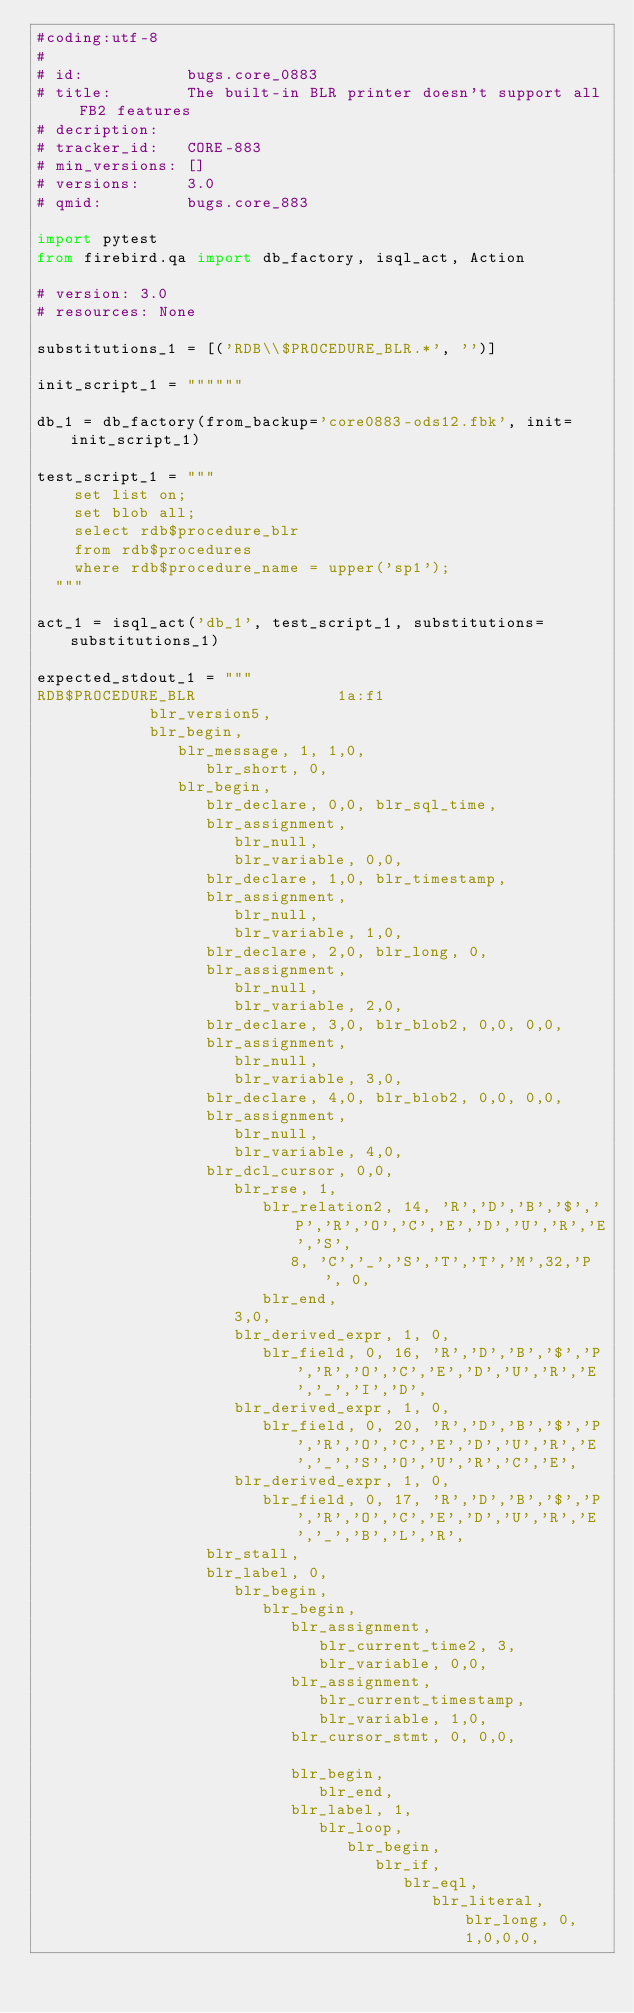<code> <loc_0><loc_0><loc_500><loc_500><_Python_>#coding:utf-8
#
# id:           bugs.core_0883
# title:        The built-in BLR printer doesn't support all FB2 features
# decription:   
# tracker_id:   CORE-883
# min_versions: []
# versions:     3.0
# qmid:         bugs.core_883

import pytest
from firebird.qa import db_factory, isql_act, Action

# version: 3.0
# resources: None

substitutions_1 = [('RDB\\$PROCEDURE_BLR.*', '')]

init_script_1 = """"""

db_1 = db_factory(from_backup='core0883-ods12.fbk', init=init_script_1)

test_script_1 = """
    set list on;
    set blob all;
    select rdb$procedure_blr
    from rdb$procedures
    where rdb$procedure_name = upper('sp1');
  """

act_1 = isql_act('db_1', test_script_1, substitutions=substitutions_1)

expected_stdout_1 = """
RDB$PROCEDURE_BLR               1a:f1
        	blr_version5,
        	blr_begin,
        	   blr_message, 1, 1,0,
        	      blr_short, 0,
        	   blr_begin,
        	      blr_declare, 0,0, blr_sql_time,
        	      blr_assignment,
        	         blr_null,
        	         blr_variable, 0,0,
        	      blr_declare, 1,0, blr_timestamp,
        	      blr_assignment,
        	         blr_null,
        	         blr_variable, 1,0,
        	      blr_declare, 2,0, blr_long, 0,
        	      blr_assignment,
        	         blr_null,
        	         blr_variable, 2,0,
        	      blr_declare, 3,0, blr_blob2, 0,0, 0,0,
        	      blr_assignment,
        	         blr_null,
        	         blr_variable, 3,0,
        	      blr_declare, 4,0, blr_blob2, 0,0, 0,0,
        	      blr_assignment,
        	         blr_null,
        	         blr_variable, 4,0,
        	      blr_dcl_cursor, 0,0,
        	         blr_rse, 1,
        	            blr_relation2, 14, 'R','D','B','$','P','R','O','C','E','D','U','R','E','S',
        	               8, 'C','_','S','T','T','M',32,'P', 0,
        	            blr_end,
        	         3,0,
        	         blr_derived_expr, 1, 0,
        	            blr_field, 0, 16, 'R','D','B','$','P','R','O','C','E','D','U','R','E','_','I','D',
        	         blr_derived_expr, 1, 0,
        	            blr_field, 0, 20, 'R','D','B','$','P','R','O','C','E','D','U','R','E','_','S','O','U','R','C','E',
        	         blr_derived_expr, 1, 0,
        	            blr_field, 0, 17, 'R','D','B','$','P','R','O','C','E','D','U','R','E','_','B','L','R',
        	      blr_stall,
        	      blr_label, 0,
        	         blr_begin,
        	            blr_begin,
        	               blr_assignment,
        	                  blr_current_time2, 3,
        	                  blr_variable, 0,0,
        	               blr_assignment,
        	                  blr_current_timestamp,
        	                  blr_variable, 1,0,
        	               blr_cursor_stmt, 0, 0,0,
        	
        	               blr_begin,
        	                  blr_end,
        	               blr_label, 1,
        	                  blr_loop,
        	                     blr_begin,
        	                        blr_if,
        	                           blr_eql,
        	                              blr_literal, blr_long, 0, 1,0,0,0,</code> 